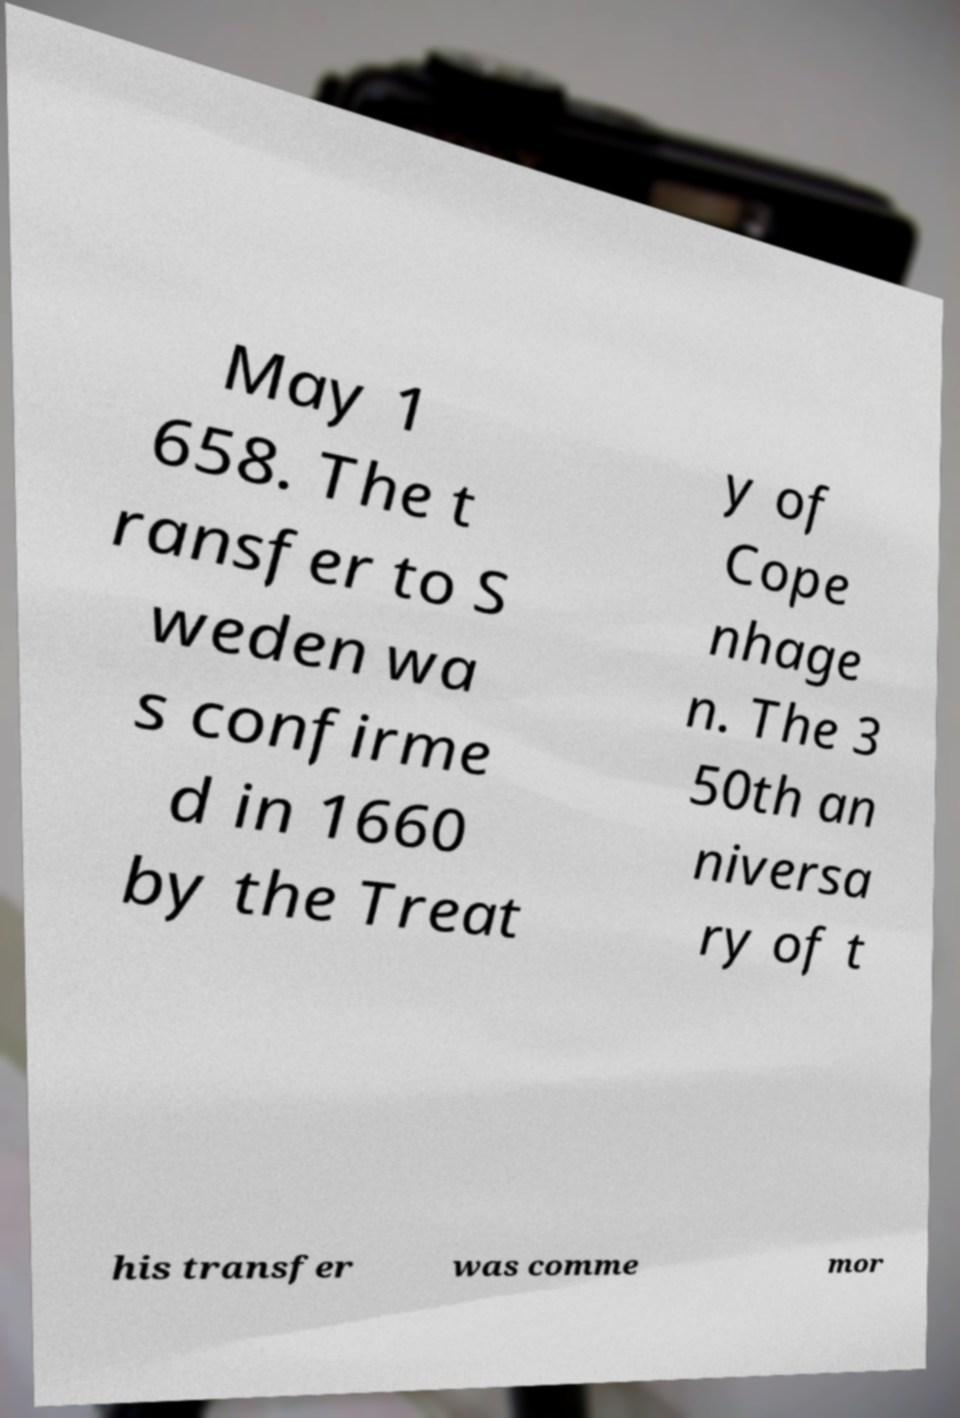Can you read and provide the text displayed in the image?This photo seems to have some interesting text. Can you extract and type it out for me? May 1 658. The t ransfer to S weden wa s confirme d in 1660 by the Treat y of Cope nhage n. The 3 50th an niversa ry of t his transfer was comme mor 